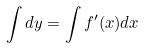Convert formula to latex. <formula><loc_0><loc_0><loc_500><loc_500>\int d y = \int f ^ { \prime } ( x ) d x</formula> 